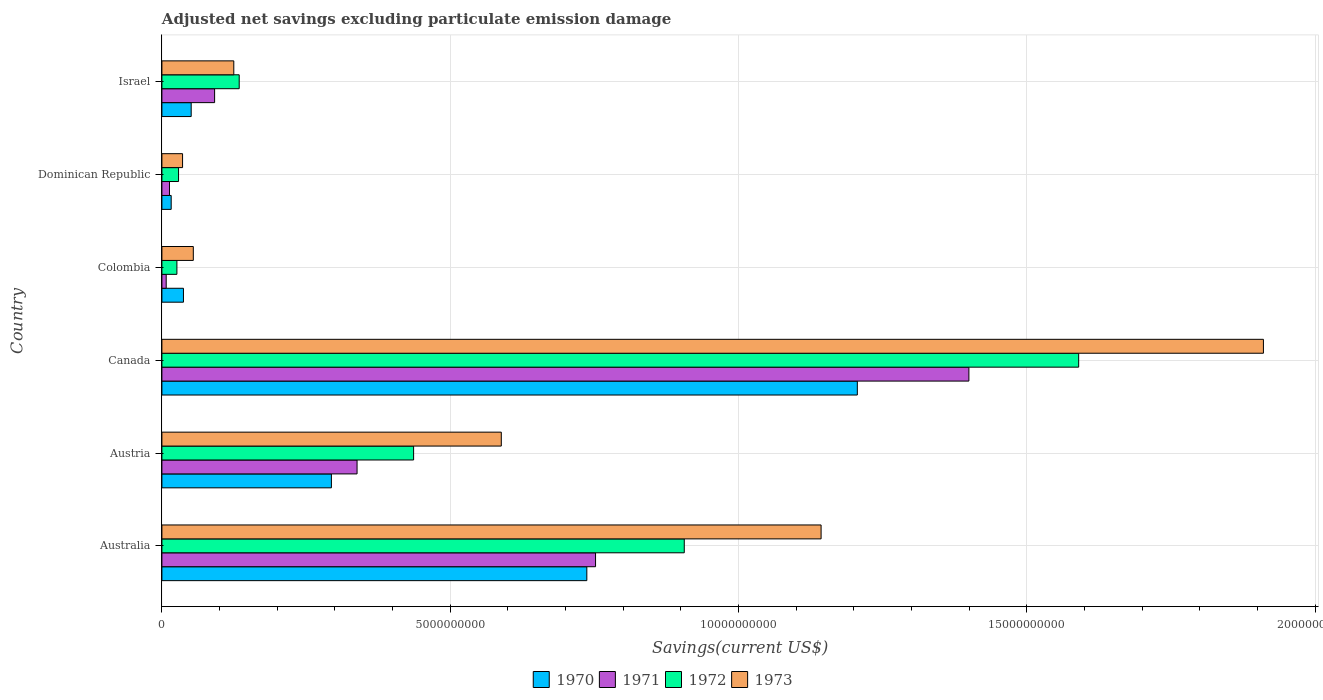How many different coloured bars are there?
Keep it short and to the point. 4. Are the number of bars on each tick of the Y-axis equal?
Make the answer very short. Yes. How many bars are there on the 6th tick from the top?
Keep it short and to the point. 4. In how many cases, is the number of bars for a given country not equal to the number of legend labels?
Give a very brief answer. 0. What is the adjusted net savings in 1972 in Canada?
Give a very brief answer. 1.59e+1. Across all countries, what is the maximum adjusted net savings in 1973?
Offer a terse response. 1.91e+1. Across all countries, what is the minimum adjusted net savings in 1970?
Make the answer very short. 1.61e+08. In which country was the adjusted net savings in 1972 minimum?
Your answer should be compact. Colombia. What is the total adjusted net savings in 1973 in the graph?
Give a very brief answer. 3.86e+1. What is the difference between the adjusted net savings in 1970 in Australia and that in Austria?
Provide a succinct answer. 4.43e+09. What is the difference between the adjusted net savings in 1972 in Austria and the adjusted net savings in 1971 in Colombia?
Your response must be concise. 4.29e+09. What is the average adjusted net savings in 1970 per country?
Your response must be concise. 3.90e+09. What is the difference between the adjusted net savings in 1971 and adjusted net savings in 1970 in Dominican Republic?
Offer a very short reply. -2.96e+07. What is the ratio of the adjusted net savings in 1971 in Dominican Republic to that in Israel?
Provide a succinct answer. 0.14. What is the difference between the highest and the second highest adjusted net savings in 1971?
Give a very brief answer. 6.48e+09. What is the difference between the highest and the lowest adjusted net savings in 1970?
Your answer should be compact. 1.19e+1. In how many countries, is the adjusted net savings in 1973 greater than the average adjusted net savings in 1973 taken over all countries?
Give a very brief answer. 2. Is the sum of the adjusted net savings in 1971 in Austria and Canada greater than the maximum adjusted net savings in 1973 across all countries?
Provide a succinct answer. No. Is it the case that in every country, the sum of the adjusted net savings in 1972 and adjusted net savings in 1973 is greater than the sum of adjusted net savings in 1971 and adjusted net savings in 1970?
Make the answer very short. No. What does the 1st bar from the bottom in Israel represents?
Your response must be concise. 1970. What is the difference between two consecutive major ticks on the X-axis?
Provide a succinct answer. 5.00e+09. Does the graph contain any zero values?
Provide a succinct answer. No. Where does the legend appear in the graph?
Your response must be concise. Bottom center. What is the title of the graph?
Provide a succinct answer. Adjusted net savings excluding particulate emission damage. What is the label or title of the X-axis?
Ensure brevity in your answer.  Savings(current US$). What is the label or title of the Y-axis?
Give a very brief answer. Country. What is the Savings(current US$) of 1970 in Australia?
Your answer should be very brief. 7.37e+09. What is the Savings(current US$) of 1971 in Australia?
Your answer should be very brief. 7.52e+09. What is the Savings(current US$) in 1972 in Australia?
Keep it short and to the point. 9.06e+09. What is the Savings(current US$) of 1973 in Australia?
Your response must be concise. 1.14e+1. What is the Savings(current US$) in 1970 in Austria?
Provide a succinct answer. 2.94e+09. What is the Savings(current US$) of 1971 in Austria?
Ensure brevity in your answer.  3.38e+09. What is the Savings(current US$) of 1972 in Austria?
Ensure brevity in your answer.  4.37e+09. What is the Savings(current US$) of 1973 in Austria?
Your answer should be very brief. 5.89e+09. What is the Savings(current US$) in 1970 in Canada?
Your response must be concise. 1.21e+1. What is the Savings(current US$) of 1971 in Canada?
Your answer should be very brief. 1.40e+1. What is the Savings(current US$) in 1972 in Canada?
Your answer should be compact. 1.59e+1. What is the Savings(current US$) of 1973 in Canada?
Ensure brevity in your answer.  1.91e+1. What is the Savings(current US$) in 1970 in Colombia?
Keep it short and to the point. 3.74e+08. What is the Savings(current US$) in 1971 in Colombia?
Offer a terse response. 7.46e+07. What is the Savings(current US$) of 1972 in Colombia?
Offer a very short reply. 2.60e+08. What is the Savings(current US$) of 1973 in Colombia?
Your answer should be very brief. 5.45e+08. What is the Savings(current US$) of 1970 in Dominican Republic?
Provide a succinct answer. 1.61e+08. What is the Savings(current US$) of 1971 in Dominican Republic?
Your answer should be compact. 1.32e+08. What is the Savings(current US$) of 1972 in Dominican Republic?
Your answer should be compact. 2.89e+08. What is the Savings(current US$) of 1973 in Dominican Republic?
Provide a succinct answer. 3.58e+08. What is the Savings(current US$) of 1970 in Israel?
Provide a short and direct response. 5.08e+08. What is the Savings(current US$) in 1971 in Israel?
Give a very brief answer. 9.14e+08. What is the Savings(current US$) in 1972 in Israel?
Ensure brevity in your answer.  1.34e+09. What is the Savings(current US$) in 1973 in Israel?
Your response must be concise. 1.25e+09. Across all countries, what is the maximum Savings(current US$) in 1970?
Your answer should be very brief. 1.21e+1. Across all countries, what is the maximum Savings(current US$) of 1971?
Make the answer very short. 1.40e+1. Across all countries, what is the maximum Savings(current US$) in 1972?
Your answer should be compact. 1.59e+1. Across all countries, what is the maximum Savings(current US$) in 1973?
Keep it short and to the point. 1.91e+1. Across all countries, what is the minimum Savings(current US$) in 1970?
Your answer should be very brief. 1.61e+08. Across all countries, what is the minimum Savings(current US$) in 1971?
Make the answer very short. 7.46e+07. Across all countries, what is the minimum Savings(current US$) in 1972?
Offer a very short reply. 2.60e+08. Across all countries, what is the minimum Savings(current US$) in 1973?
Give a very brief answer. 3.58e+08. What is the total Savings(current US$) in 1970 in the graph?
Keep it short and to the point. 2.34e+1. What is the total Savings(current US$) in 1971 in the graph?
Make the answer very short. 2.60e+1. What is the total Savings(current US$) of 1972 in the graph?
Provide a succinct answer. 3.12e+1. What is the total Savings(current US$) in 1973 in the graph?
Provide a succinct answer. 3.86e+1. What is the difference between the Savings(current US$) of 1970 in Australia and that in Austria?
Your answer should be very brief. 4.43e+09. What is the difference between the Savings(current US$) of 1971 in Australia and that in Austria?
Your answer should be very brief. 4.14e+09. What is the difference between the Savings(current US$) in 1972 in Australia and that in Austria?
Your answer should be compact. 4.69e+09. What is the difference between the Savings(current US$) in 1973 in Australia and that in Austria?
Give a very brief answer. 5.55e+09. What is the difference between the Savings(current US$) in 1970 in Australia and that in Canada?
Your response must be concise. -4.69e+09. What is the difference between the Savings(current US$) in 1971 in Australia and that in Canada?
Ensure brevity in your answer.  -6.48e+09. What is the difference between the Savings(current US$) of 1972 in Australia and that in Canada?
Make the answer very short. -6.84e+09. What is the difference between the Savings(current US$) in 1973 in Australia and that in Canada?
Make the answer very short. -7.67e+09. What is the difference between the Savings(current US$) of 1970 in Australia and that in Colombia?
Keep it short and to the point. 7.00e+09. What is the difference between the Savings(current US$) in 1971 in Australia and that in Colombia?
Provide a short and direct response. 7.45e+09. What is the difference between the Savings(current US$) in 1972 in Australia and that in Colombia?
Ensure brevity in your answer.  8.80e+09. What is the difference between the Savings(current US$) in 1973 in Australia and that in Colombia?
Offer a terse response. 1.09e+1. What is the difference between the Savings(current US$) in 1970 in Australia and that in Dominican Republic?
Make the answer very short. 7.21e+09. What is the difference between the Savings(current US$) of 1971 in Australia and that in Dominican Republic?
Offer a terse response. 7.39e+09. What is the difference between the Savings(current US$) of 1972 in Australia and that in Dominican Republic?
Give a very brief answer. 8.77e+09. What is the difference between the Savings(current US$) in 1973 in Australia and that in Dominican Republic?
Offer a very short reply. 1.11e+1. What is the difference between the Savings(current US$) in 1970 in Australia and that in Israel?
Provide a succinct answer. 6.86e+09. What is the difference between the Savings(current US$) of 1971 in Australia and that in Israel?
Your response must be concise. 6.61e+09. What is the difference between the Savings(current US$) in 1972 in Australia and that in Israel?
Your response must be concise. 7.72e+09. What is the difference between the Savings(current US$) of 1973 in Australia and that in Israel?
Keep it short and to the point. 1.02e+1. What is the difference between the Savings(current US$) in 1970 in Austria and that in Canada?
Your answer should be very brief. -9.12e+09. What is the difference between the Savings(current US$) in 1971 in Austria and that in Canada?
Give a very brief answer. -1.06e+1. What is the difference between the Savings(current US$) in 1972 in Austria and that in Canada?
Your response must be concise. -1.15e+1. What is the difference between the Savings(current US$) in 1973 in Austria and that in Canada?
Give a very brief answer. -1.32e+1. What is the difference between the Savings(current US$) of 1970 in Austria and that in Colombia?
Your answer should be very brief. 2.57e+09. What is the difference between the Savings(current US$) of 1971 in Austria and that in Colombia?
Keep it short and to the point. 3.31e+09. What is the difference between the Savings(current US$) in 1972 in Austria and that in Colombia?
Provide a short and direct response. 4.11e+09. What is the difference between the Savings(current US$) of 1973 in Austria and that in Colombia?
Your answer should be very brief. 5.34e+09. What is the difference between the Savings(current US$) of 1970 in Austria and that in Dominican Republic?
Make the answer very short. 2.78e+09. What is the difference between the Savings(current US$) in 1971 in Austria and that in Dominican Republic?
Provide a short and direct response. 3.25e+09. What is the difference between the Savings(current US$) in 1972 in Austria and that in Dominican Republic?
Keep it short and to the point. 4.08e+09. What is the difference between the Savings(current US$) of 1973 in Austria and that in Dominican Republic?
Provide a short and direct response. 5.53e+09. What is the difference between the Savings(current US$) of 1970 in Austria and that in Israel?
Offer a terse response. 2.43e+09. What is the difference between the Savings(current US$) of 1971 in Austria and that in Israel?
Your answer should be compact. 2.47e+09. What is the difference between the Savings(current US$) of 1972 in Austria and that in Israel?
Your answer should be very brief. 3.02e+09. What is the difference between the Savings(current US$) of 1973 in Austria and that in Israel?
Offer a terse response. 4.64e+09. What is the difference between the Savings(current US$) in 1970 in Canada and that in Colombia?
Make the answer very short. 1.17e+1. What is the difference between the Savings(current US$) in 1971 in Canada and that in Colombia?
Your answer should be compact. 1.39e+1. What is the difference between the Savings(current US$) in 1972 in Canada and that in Colombia?
Give a very brief answer. 1.56e+1. What is the difference between the Savings(current US$) in 1973 in Canada and that in Colombia?
Provide a short and direct response. 1.86e+1. What is the difference between the Savings(current US$) of 1970 in Canada and that in Dominican Republic?
Offer a terse response. 1.19e+1. What is the difference between the Savings(current US$) of 1971 in Canada and that in Dominican Republic?
Provide a short and direct response. 1.39e+1. What is the difference between the Savings(current US$) in 1972 in Canada and that in Dominican Republic?
Keep it short and to the point. 1.56e+1. What is the difference between the Savings(current US$) in 1973 in Canada and that in Dominican Republic?
Ensure brevity in your answer.  1.87e+1. What is the difference between the Savings(current US$) in 1970 in Canada and that in Israel?
Offer a very short reply. 1.16e+1. What is the difference between the Savings(current US$) of 1971 in Canada and that in Israel?
Offer a terse response. 1.31e+1. What is the difference between the Savings(current US$) of 1972 in Canada and that in Israel?
Offer a very short reply. 1.46e+1. What is the difference between the Savings(current US$) of 1973 in Canada and that in Israel?
Provide a short and direct response. 1.79e+1. What is the difference between the Savings(current US$) of 1970 in Colombia and that in Dominican Republic?
Your answer should be very brief. 2.13e+08. What is the difference between the Savings(current US$) of 1971 in Colombia and that in Dominican Republic?
Offer a terse response. -5.69e+07. What is the difference between the Savings(current US$) in 1972 in Colombia and that in Dominican Republic?
Ensure brevity in your answer.  -2.84e+07. What is the difference between the Savings(current US$) of 1973 in Colombia and that in Dominican Republic?
Your response must be concise. 1.87e+08. What is the difference between the Savings(current US$) of 1970 in Colombia and that in Israel?
Your response must be concise. -1.34e+08. What is the difference between the Savings(current US$) in 1971 in Colombia and that in Israel?
Provide a succinct answer. -8.40e+08. What is the difference between the Savings(current US$) in 1972 in Colombia and that in Israel?
Offer a very short reply. -1.08e+09. What is the difference between the Savings(current US$) in 1973 in Colombia and that in Israel?
Provide a succinct answer. -7.02e+08. What is the difference between the Savings(current US$) in 1970 in Dominican Republic and that in Israel?
Ensure brevity in your answer.  -3.47e+08. What is the difference between the Savings(current US$) of 1971 in Dominican Republic and that in Israel?
Give a very brief answer. -7.83e+08. What is the difference between the Savings(current US$) in 1972 in Dominican Republic and that in Israel?
Ensure brevity in your answer.  -1.05e+09. What is the difference between the Savings(current US$) in 1973 in Dominican Republic and that in Israel?
Keep it short and to the point. -8.89e+08. What is the difference between the Savings(current US$) of 1970 in Australia and the Savings(current US$) of 1971 in Austria?
Offer a very short reply. 3.98e+09. What is the difference between the Savings(current US$) of 1970 in Australia and the Savings(current US$) of 1972 in Austria?
Make the answer very short. 3.00e+09. What is the difference between the Savings(current US$) of 1970 in Australia and the Savings(current US$) of 1973 in Austria?
Make the answer very short. 1.48e+09. What is the difference between the Savings(current US$) of 1971 in Australia and the Savings(current US$) of 1972 in Austria?
Your response must be concise. 3.16e+09. What is the difference between the Savings(current US$) of 1971 in Australia and the Savings(current US$) of 1973 in Austria?
Ensure brevity in your answer.  1.63e+09. What is the difference between the Savings(current US$) in 1972 in Australia and the Savings(current US$) in 1973 in Austria?
Make the answer very short. 3.17e+09. What is the difference between the Savings(current US$) in 1970 in Australia and the Savings(current US$) in 1971 in Canada?
Your answer should be very brief. -6.63e+09. What is the difference between the Savings(current US$) in 1970 in Australia and the Savings(current US$) in 1972 in Canada?
Provide a short and direct response. -8.53e+09. What is the difference between the Savings(current US$) of 1970 in Australia and the Savings(current US$) of 1973 in Canada?
Keep it short and to the point. -1.17e+1. What is the difference between the Savings(current US$) in 1971 in Australia and the Savings(current US$) in 1972 in Canada?
Make the answer very short. -8.38e+09. What is the difference between the Savings(current US$) of 1971 in Australia and the Savings(current US$) of 1973 in Canada?
Offer a very short reply. -1.16e+1. What is the difference between the Savings(current US$) in 1972 in Australia and the Savings(current US$) in 1973 in Canada?
Provide a succinct answer. -1.00e+1. What is the difference between the Savings(current US$) in 1970 in Australia and the Savings(current US$) in 1971 in Colombia?
Keep it short and to the point. 7.30e+09. What is the difference between the Savings(current US$) of 1970 in Australia and the Savings(current US$) of 1972 in Colombia?
Provide a succinct answer. 7.11e+09. What is the difference between the Savings(current US$) of 1970 in Australia and the Savings(current US$) of 1973 in Colombia?
Your answer should be compact. 6.83e+09. What is the difference between the Savings(current US$) in 1971 in Australia and the Savings(current US$) in 1972 in Colombia?
Your response must be concise. 7.26e+09. What is the difference between the Savings(current US$) in 1971 in Australia and the Savings(current US$) in 1973 in Colombia?
Ensure brevity in your answer.  6.98e+09. What is the difference between the Savings(current US$) of 1972 in Australia and the Savings(current US$) of 1973 in Colombia?
Give a very brief answer. 8.51e+09. What is the difference between the Savings(current US$) of 1970 in Australia and the Savings(current US$) of 1971 in Dominican Republic?
Provide a short and direct response. 7.24e+09. What is the difference between the Savings(current US$) of 1970 in Australia and the Savings(current US$) of 1972 in Dominican Republic?
Keep it short and to the point. 7.08e+09. What is the difference between the Savings(current US$) of 1970 in Australia and the Savings(current US$) of 1973 in Dominican Republic?
Offer a very short reply. 7.01e+09. What is the difference between the Savings(current US$) in 1971 in Australia and the Savings(current US$) in 1972 in Dominican Republic?
Your answer should be very brief. 7.23e+09. What is the difference between the Savings(current US$) of 1971 in Australia and the Savings(current US$) of 1973 in Dominican Republic?
Ensure brevity in your answer.  7.16e+09. What is the difference between the Savings(current US$) in 1972 in Australia and the Savings(current US$) in 1973 in Dominican Republic?
Your answer should be compact. 8.70e+09. What is the difference between the Savings(current US$) of 1970 in Australia and the Savings(current US$) of 1971 in Israel?
Provide a short and direct response. 6.46e+09. What is the difference between the Savings(current US$) of 1970 in Australia and the Savings(current US$) of 1972 in Israel?
Ensure brevity in your answer.  6.03e+09. What is the difference between the Savings(current US$) of 1970 in Australia and the Savings(current US$) of 1973 in Israel?
Offer a very short reply. 6.12e+09. What is the difference between the Savings(current US$) of 1971 in Australia and the Savings(current US$) of 1972 in Israel?
Make the answer very short. 6.18e+09. What is the difference between the Savings(current US$) of 1971 in Australia and the Savings(current US$) of 1973 in Israel?
Provide a succinct answer. 6.27e+09. What is the difference between the Savings(current US$) in 1972 in Australia and the Savings(current US$) in 1973 in Israel?
Your response must be concise. 7.81e+09. What is the difference between the Savings(current US$) in 1970 in Austria and the Savings(current US$) in 1971 in Canada?
Your response must be concise. -1.11e+1. What is the difference between the Savings(current US$) of 1970 in Austria and the Savings(current US$) of 1972 in Canada?
Make the answer very short. -1.30e+1. What is the difference between the Savings(current US$) of 1970 in Austria and the Savings(current US$) of 1973 in Canada?
Provide a short and direct response. -1.62e+1. What is the difference between the Savings(current US$) in 1971 in Austria and the Savings(current US$) in 1972 in Canada?
Keep it short and to the point. -1.25e+1. What is the difference between the Savings(current US$) of 1971 in Austria and the Savings(current US$) of 1973 in Canada?
Your answer should be compact. -1.57e+1. What is the difference between the Savings(current US$) of 1972 in Austria and the Savings(current US$) of 1973 in Canada?
Ensure brevity in your answer.  -1.47e+1. What is the difference between the Savings(current US$) of 1970 in Austria and the Savings(current US$) of 1971 in Colombia?
Offer a very short reply. 2.87e+09. What is the difference between the Savings(current US$) in 1970 in Austria and the Savings(current US$) in 1972 in Colombia?
Offer a terse response. 2.68e+09. What is the difference between the Savings(current US$) of 1970 in Austria and the Savings(current US$) of 1973 in Colombia?
Ensure brevity in your answer.  2.40e+09. What is the difference between the Savings(current US$) of 1971 in Austria and the Savings(current US$) of 1972 in Colombia?
Your response must be concise. 3.12e+09. What is the difference between the Savings(current US$) in 1971 in Austria and the Savings(current US$) in 1973 in Colombia?
Your answer should be compact. 2.84e+09. What is the difference between the Savings(current US$) of 1972 in Austria and the Savings(current US$) of 1973 in Colombia?
Give a very brief answer. 3.82e+09. What is the difference between the Savings(current US$) in 1970 in Austria and the Savings(current US$) in 1971 in Dominican Republic?
Offer a terse response. 2.81e+09. What is the difference between the Savings(current US$) in 1970 in Austria and the Savings(current US$) in 1972 in Dominican Republic?
Your response must be concise. 2.65e+09. What is the difference between the Savings(current US$) of 1970 in Austria and the Savings(current US$) of 1973 in Dominican Republic?
Offer a very short reply. 2.58e+09. What is the difference between the Savings(current US$) of 1971 in Austria and the Savings(current US$) of 1972 in Dominican Republic?
Your response must be concise. 3.10e+09. What is the difference between the Savings(current US$) of 1971 in Austria and the Savings(current US$) of 1973 in Dominican Republic?
Your answer should be compact. 3.03e+09. What is the difference between the Savings(current US$) in 1972 in Austria and the Savings(current US$) in 1973 in Dominican Republic?
Ensure brevity in your answer.  4.01e+09. What is the difference between the Savings(current US$) in 1970 in Austria and the Savings(current US$) in 1971 in Israel?
Offer a terse response. 2.03e+09. What is the difference between the Savings(current US$) of 1970 in Austria and the Savings(current US$) of 1972 in Israel?
Give a very brief answer. 1.60e+09. What is the difference between the Savings(current US$) of 1970 in Austria and the Savings(current US$) of 1973 in Israel?
Keep it short and to the point. 1.69e+09. What is the difference between the Savings(current US$) of 1971 in Austria and the Savings(current US$) of 1972 in Israel?
Offer a very short reply. 2.04e+09. What is the difference between the Savings(current US$) of 1971 in Austria and the Savings(current US$) of 1973 in Israel?
Make the answer very short. 2.14e+09. What is the difference between the Savings(current US$) of 1972 in Austria and the Savings(current US$) of 1973 in Israel?
Provide a short and direct response. 3.12e+09. What is the difference between the Savings(current US$) of 1970 in Canada and the Savings(current US$) of 1971 in Colombia?
Offer a terse response. 1.20e+1. What is the difference between the Savings(current US$) of 1970 in Canada and the Savings(current US$) of 1972 in Colombia?
Ensure brevity in your answer.  1.18e+1. What is the difference between the Savings(current US$) in 1970 in Canada and the Savings(current US$) in 1973 in Colombia?
Your response must be concise. 1.15e+1. What is the difference between the Savings(current US$) of 1971 in Canada and the Savings(current US$) of 1972 in Colombia?
Give a very brief answer. 1.37e+1. What is the difference between the Savings(current US$) in 1971 in Canada and the Savings(current US$) in 1973 in Colombia?
Provide a short and direct response. 1.35e+1. What is the difference between the Savings(current US$) of 1972 in Canada and the Savings(current US$) of 1973 in Colombia?
Your answer should be very brief. 1.54e+1. What is the difference between the Savings(current US$) in 1970 in Canada and the Savings(current US$) in 1971 in Dominican Republic?
Ensure brevity in your answer.  1.19e+1. What is the difference between the Savings(current US$) of 1970 in Canada and the Savings(current US$) of 1972 in Dominican Republic?
Your response must be concise. 1.18e+1. What is the difference between the Savings(current US$) of 1970 in Canada and the Savings(current US$) of 1973 in Dominican Republic?
Offer a terse response. 1.17e+1. What is the difference between the Savings(current US$) of 1971 in Canada and the Savings(current US$) of 1972 in Dominican Republic?
Ensure brevity in your answer.  1.37e+1. What is the difference between the Savings(current US$) in 1971 in Canada and the Savings(current US$) in 1973 in Dominican Republic?
Your answer should be very brief. 1.36e+1. What is the difference between the Savings(current US$) of 1972 in Canada and the Savings(current US$) of 1973 in Dominican Republic?
Give a very brief answer. 1.55e+1. What is the difference between the Savings(current US$) of 1970 in Canada and the Savings(current US$) of 1971 in Israel?
Make the answer very short. 1.11e+1. What is the difference between the Savings(current US$) in 1970 in Canada and the Savings(current US$) in 1972 in Israel?
Your response must be concise. 1.07e+1. What is the difference between the Savings(current US$) of 1970 in Canada and the Savings(current US$) of 1973 in Israel?
Keep it short and to the point. 1.08e+1. What is the difference between the Savings(current US$) of 1971 in Canada and the Savings(current US$) of 1972 in Israel?
Your answer should be compact. 1.27e+1. What is the difference between the Savings(current US$) in 1971 in Canada and the Savings(current US$) in 1973 in Israel?
Your response must be concise. 1.27e+1. What is the difference between the Savings(current US$) of 1972 in Canada and the Savings(current US$) of 1973 in Israel?
Your response must be concise. 1.47e+1. What is the difference between the Savings(current US$) of 1970 in Colombia and the Savings(current US$) of 1971 in Dominican Republic?
Offer a terse response. 2.42e+08. What is the difference between the Savings(current US$) of 1970 in Colombia and the Savings(current US$) of 1972 in Dominican Republic?
Make the answer very short. 8.52e+07. What is the difference between the Savings(current US$) in 1970 in Colombia and the Savings(current US$) in 1973 in Dominican Republic?
Keep it short and to the point. 1.57e+07. What is the difference between the Savings(current US$) in 1971 in Colombia and the Savings(current US$) in 1972 in Dominican Republic?
Your answer should be compact. -2.14e+08. What is the difference between the Savings(current US$) in 1971 in Colombia and the Savings(current US$) in 1973 in Dominican Republic?
Give a very brief answer. -2.84e+08. What is the difference between the Savings(current US$) of 1972 in Colombia and the Savings(current US$) of 1973 in Dominican Republic?
Your answer should be very brief. -9.79e+07. What is the difference between the Savings(current US$) in 1970 in Colombia and the Savings(current US$) in 1971 in Israel?
Your answer should be compact. -5.40e+08. What is the difference between the Savings(current US$) in 1970 in Colombia and the Savings(current US$) in 1972 in Israel?
Ensure brevity in your answer.  -9.67e+08. What is the difference between the Savings(current US$) in 1970 in Colombia and the Savings(current US$) in 1973 in Israel?
Provide a short and direct response. -8.73e+08. What is the difference between the Savings(current US$) in 1971 in Colombia and the Savings(current US$) in 1972 in Israel?
Ensure brevity in your answer.  -1.27e+09. What is the difference between the Savings(current US$) in 1971 in Colombia and the Savings(current US$) in 1973 in Israel?
Your response must be concise. -1.17e+09. What is the difference between the Savings(current US$) in 1972 in Colombia and the Savings(current US$) in 1973 in Israel?
Your answer should be very brief. -9.87e+08. What is the difference between the Savings(current US$) in 1970 in Dominican Republic and the Savings(current US$) in 1971 in Israel?
Provide a succinct answer. -7.53e+08. What is the difference between the Savings(current US$) of 1970 in Dominican Republic and the Savings(current US$) of 1972 in Israel?
Make the answer very short. -1.18e+09. What is the difference between the Savings(current US$) in 1970 in Dominican Republic and the Savings(current US$) in 1973 in Israel?
Provide a succinct answer. -1.09e+09. What is the difference between the Savings(current US$) of 1971 in Dominican Republic and the Savings(current US$) of 1972 in Israel?
Give a very brief answer. -1.21e+09. What is the difference between the Savings(current US$) in 1971 in Dominican Republic and the Savings(current US$) in 1973 in Israel?
Provide a short and direct response. -1.12e+09. What is the difference between the Savings(current US$) in 1972 in Dominican Republic and the Savings(current US$) in 1973 in Israel?
Ensure brevity in your answer.  -9.58e+08. What is the average Savings(current US$) in 1970 per country?
Your response must be concise. 3.90e+09. What is the average Savings(current US$) in 1971 per country?
Your answer should be very brief. 4.34e+09. What is the average Savings(current US$) in 1972 per country?
Offer a very short reply. 5.20e+09. What is the average Savings(current US$) in 1973 per country?
Make the answer very short. 6.43e+09. What is the difference between the Savings(current US$) in 1970 and Savings(current US$) in 1971 in Australia?
Your answer should be compact. -1.51e+08. What is the difference between the Savings(current US$) in 1970 and Savings(current US$) in 1972 in Australia?
Offer a very short reply. -1.69e+09. What is the difference between the Savings(current US$) of 1970 and Savings(current US$) of 1973 in Australia?
Provide a short and direct response. -4.06e+09. What is the difference between the Savings(current US$) in 1971 and Savings(current US$) in 1972 in Australia?
Ensure brevity in your answer.  -1.54e+09. What is the difference between the Savings(current US$) in 1971 and Savings(current US$) in 1973 in Australia?
Keep it short and to the point. -3.91e+09. What is the difference between the Savings(current US$) of 1972 and Savings(current US$) of 1973 in Australia?
Your answer should be very brief. -2.37e+09. What is the difference between the Savings(current US$) of 1970 and Savings(current US$) of 1971 in Austria?
Offer a terse response. -4.45e+08. What is the difference between the Savings(current US$) of 1970 and Savings(current US$) of 1972 in Austria?
Your answer should be compact. -1.43e+09. What is the difference between the Savings(current US$) in 1970 and Savings(current US$) in 1973 in Austria?
Your answer should be compact. -2.95e+09. What is the difference between the Savings(current US$) in 1971 and Savings(current US$) in 1972 in Austria?
Provide a short and direct response. -9.81e+08. What is the difference between the Savings(current US$) of 1971 and Savings(current US$) of 1973 in Austria?
Your answer should be very brief. -2.50e+09. What is the difference between the Savings(current US$) of 1972 and Savings(current US$) of 1973 in Austria?
Keep it short and to the point. -1.52e+09. What is the difference between the Savings(current US$) in 1970 and Savings(current US$) in 1971 in Canada?
Your answer should be compact. -1.94e+09. What is the difference between the Savings(current US$) in 1970 and Savings(current US$) in 1972 in Canada?
Your response must be concise. -3.84e+09. What is the difference between the Savings(current US$) of 1970 and Savings(current US$) of 1973 in Canada?
Provide a short and direct response. -7.04e+09. What is the difference between the Savings(current US$) of 1971 and Savings(current US$) of 1972 in Canada?
Make the answer very short. -1.90e+09. What is the difference between the Savings(current US$) in 1971 and Savings(current US$) in 1973 in Canada?
Your answer should be compact. -5.11e+09. What is the difference between the Savings(current US$) of 1972 and Savings(current US$) of 1973 in Canada?
Offer a terse response. -3.20e+09. What is the difference between the Savings(current US$) in 1970 and Savings(current US$) in 1971 in Colombia?
Your response must be concise. 2.99e+08. What is the difference between the Savings(current US$) of 1970 and Savings(current US$) of 1972 in Colombia?
Offer a very short reply. 1.14e+08. What is the difference between the Savings(current US$) of 1970 and Savings(current US$) of 1973 in Colombia?
Your answer should be very brief. -1.71e+08. What is the difference between the Savings(current US$) in 1971 and Savings(current US$) in 1972 in Colombia?
Offer a terse response. -1.86e+08. What is the difference between the Savings(current US$) in 1971 and Savings(current US$) in 1973 in Colombia?
Provide a short and direct response. -4.70e+08. What is the difference between the Savings(current US$) in 1972 and Savings(current US$) in 1973 in Colombia?
Provide a short and direct response. -2.85e+08. What is the difference between the Savings(current US$) of 1970 and Savings(current US$) of 1971 in Dominican Republic?
Provide a succinct answer. 2.96e+07. What is the difference between the Savings(current US$) of 1970 and Savings(current US$) of 1972 in Dominican Republic?
Your answer should be compact. -1.28e+08. What is the difference between the Savings(current US$) of 1970 and Savings(current US$) of 1973 in Dominican Republic?
Offer a very short reply. -1.97e+08. What is the difference between the Savings(current US$) in 1971 and Savings(current US$) in 1972 in Dominican Republic?
Give a very brief answer. -1.57e+08. What is the difference between the Savings(current US$) in 1971 and Savings(current US$) in 1973 in Dominican Republic?
Offer a very short reply. -2.27e+08. What is the difference between the Savings(current US$) of 1972 and Savings(current US$) of 1973 in Dominican Republic?
Offer a very short reply. -6.95e+07. What is the difference between the Savings(current US$) of 1970 and Savings(current US$) of 1971 in Israel?
Offer a terse response. -4.06e+08. What is the difference between the Savings(current US$) of 1970 and Savings(current US$) of 1972 in Israel?
Offer a terse response. -8.33e+08. What is the difference between the Savings(current US$) of 1970 and Savings(current US$) of 1973 in Israel?
Provide a succinct answer. -7.39e+08. What is the difference between the Savings(current US$) in 1971 and Savings(current US$) in 1972 in Israel?
Your answer should be compact. -4.27e+08. What is the difference between the Savings(current US$) of 1971 and Savings(current US$) of 1973 in Israel?
Provide a succinct answer. -3.33e+08. What is the difference between the Savings(current US$) of 1972 and Savings(current US$) of 1973 in Israel?
Provide a short and direct response. 9.40e+07. What is the ratio of the Savings(current US$) in 1970 in Australia to that in Austria?
Ensure brevity in your answer.  2.51. What is the ratio of the Savings(current US$) in 1971 in Australia to that in Austria?
Offer a very short reply. 2.22. What is the ratio of the Savings(current US$) in 1972 in Australia to that in Austria?
Give a very brief answer. 2.08. What is the ratio of the Savings(current US$) of 1973 in Australia to that in Austria?
Your answer should be very brief. 1.94. What is the ratio of the Savings(current US$) in 1970 in Australia to that in Canada?
Your answer should be compact. 0.61. What is the ratio of the Savings(current US$) of 1971 in Australia to that in Canada?
Offer a very short reply. 0.54. What is the ratio of the Savings(current US$) of 1972 in Australia to that in Canada?
Make the answer very short. 0.57. What is the ratio of the Savings(current US$) of 1973 in Australia to that in Canada?
Your response must be concise. 0.6. What is the ratio of the Savings(current US$) in 1970 in Australia to that in Colombia?
Provide a short and direct response. 19.71. What is the ratio of the Savings(current US$) in 1971 in Australia to that in Colombia?
Give a very brief answer. 100.8. What is the ratio of the Savings(current US$) of 1972 in Australia to that in Colombia?
Your response must be concise. 34.81. What is the ratio of the Savings(current US$) of 1973 in Australia to that in Colombia?
Ensure brevity in your answer.  20.98. What is the ratio of the Savings(current US$) of 1970 in Australia to that in Dominican Republic?
Your response must be concise. 45.75. What is the ratio of the Savings(current US$) of 1971 in Australia to that in Dominican Republic?
Keep it short and to the point. 57.18. What is the ratio of the Savings(current US$) of 1972 in Australia to that in Dominican Republic?
Offer a terse response. 31.38. What is the ratio of the Savings(current US$) of 1973 in Australia to that in Dominican Republic?
Give a very brief answer. 31.92. What is the ratio of the Savings(current US$) in 1970 in Australia to that in Israel?
Provide a short and direct response. 14.51. What is the ratio of the Savings(current US$) of 1971 in Australia to that in Israel?
Keep it short and to the point. 8.23. What is the ratio of the Savings(current US$) in 1972 in Australia to that in Israel?
Provide a short and direct response. 6.76. What is the ratio of the Savings(current US$) in 1973 in Australia to that in Israel?
Offer a terse response. 9.17. What is the ratio of the Savings(current US$) in 1970 in Austria to that in Canada?
Make the answer very short. 0.24. What is the ratio of the Savings(current US$) in 1971 in Austria to that in Canada?
Your response must be concise. 0.24. What is the ratio of the Savings(current US$) in 1972 in Austria to that in Canada?
Ensure brevity in your answer.  0.27. What is the ratio of the Savings(current US$) in 1973 in Austria to that in Canada?
Give a very brief answer. 0.31. What is the ratio of the Savings(current US$) of 1970 in Austria to that in Colombia?
Offer a terse response. 7.86. What is the ratio of the Savings(current US$) of 1971 in Austria to that in Colombia?
Offer a very short reply. 45.37. What is the ratio of the Savings(current US$) of 1972 in Austria to that in Colombia?
Offer a very short reply. 16.77. What is the ratio of the Savings(current US$) in 1973 in Austria to that in Colombia?
Offer a very short reply. 10.8. What is the ratio of the Savings(current US$) of 1970 in Austria to that in Dominican Republic?
Provide a short and direct response. 18.25. What is the ratio of the Savings(current US$) of 1971 in Austria to that in Dominican Republic?
Make the answer very short. 25.73. What is the ratio of the Savings(current US$) in 1972 in Austria to that in Dominican Republic?
Your answer should be compact. 15.12. What is the ratio of the Savings(current US$) in 1973 in Austria to that in Dominican Republic?
Offer a terse response. 16.43. What is the ratio of the Savings(current US$) in 1970 in Austria to that in Israel?
Offer a very short reply. 5.79. What is the ratio of the Savings(current US$) in 1971 in Austria to that in Israel?
Keep it short and to the point. 3.7. What is the ratio of the Savings(current US$) in 1972 in Austria to that in Israel?
Your response must be concise. 3.26. What is the ratio of the Savings(current US$) in 1973 in Austria to that in Israel?
Your answer should be very brief. 4.72. What is the ratio of the Savings(current US$) in 1970 in Canada to that in Colombia?
Your answer should be compact. 32.26. What is the ratio of the Savings(current US$) of 1971 in Canada to that in Colombia?
Your response must be concise. 187.59. What is the ratio of the Savings(current US$) of 1972 in Canada to that in Colombia?
Offer a very short reply. 61.09. What is the ratio of the Savings(current US$) of 1973 in Canada to that in Colombia?
Your response must be concise. 35.07. What is the ratio of the Savings(current US$) in 1970 in Canada to that in Dominican Republic?
Keep it short and to the point. 74.87. What is the ratio of the Savings(current US$) of 1971 in Canada to that in Dominican Republic?
Your answer should be very brief. 106.4. What is the ratio of the Savings(current US$) in 1972 in Canada to that in Dominican Republic?
Give a very brief answer. 55.08. What is the ratio of the Savings(current US$) in 1973 in Canada to that in Dominican Republic?
Offer a terse response. 53.33. What is the ratio of the Savings(current US$) of 1970 in Canada to that in Israel?
Ensure brevity in your answer.  23.75. What is the ratio of the Savings(current US$) of 1971 in Canada to that in Israel?
Make the answer very short. 15.31. What is the ratio of the Savings(current US$) of 1972 in Canada to that in Israel?
Your answer should be very brief. 11.86. What is the ratio of the Savings(current US$) in 1973 in Canada to that in Israel?
Your answer should be compact. 15.32. What is the ratio of the Savings(current US$) in 1970 in Colombia to that in Dominican Republic?
Make the answer very short. 2.32. What is the ratio of the Savings(current US$) in 1971 in Colombia to that in Dominican Republic?
Your answer should be very brief. 0.57. What is the ratio of the Savings(current US$) in 1972 in Colombia to that in Dominican Republic?
Offer a very short reply. 0.9. What is the ratio of the Savings(current US$) of 1973 in Colombia to that in Dominican Republic?
Offer a very short reply. 1.52. What is the ratio of the Savings(current US$) of 1970 in Colombia to that in Israel?
Your answer should be compact. 0.74. What is the ratio of the Savings(current US$) in 1971 in Colombia to that in Israel?
Provide a short and direct response. 0.08. What is the ratio of the Savings(current US$) in 1972 in Colombia to that in Israel?
Your answer should be compact. 0.19. What is the ratio of the Savings(current US$) in 1973 in Colombia to that in Israel?
Provide a short and direct response. 0.44. What is the ratio of the Savings(current US$) in 1970 in Dominican Republic to that in Israel?
Keep it short and to the point. 0.32. What is the ratio of the Savings(current US$) in 1971 in Dominican Republic to that in Israel?
Keep it short and to the point. 0.14. What is the ratio of the Savings(current US$) of 1972 in Dominican Republic to that in Israel?
Keep it short and to the point. 0.22. What is the ratio of the Savings(current US$) of 1973 in Dominican Republic to that in Israel?
Make the answer very short. 0.29. What is the difference between the highest and the second highest Savings(current US$) of 1970?
Offer a very short reply. 4.69e+09. What is the difference between the highest and the second highest Savings(current US$) of 1971?
Make the answer very short. 6.48e+09. What is the difference between the highest and the second highest Savings(current US$) of 1972?
Offer a terse response. 6.84e+09. What is the difference between the highest and the second highest Savings(current US$) in 1973?
Your answer should be very brief. 7.67e+09. What is the difference between the highest and the lowest Savings(current US$) of 1970?
Provide a succinct answer. 1.19e+1. What is the difference between the highest and the lowest Savings(current US$) in 1971?
Your answer should be compact. 1.39e+1. What is the difference between the highest and the lowest Savings(current US$) in 1972?
Make the answer very short. 1.56e+1. What is the difference between the highest and the lowest Savings(current US$) of 1973?
Offer a terse response. 1.87e+1. 